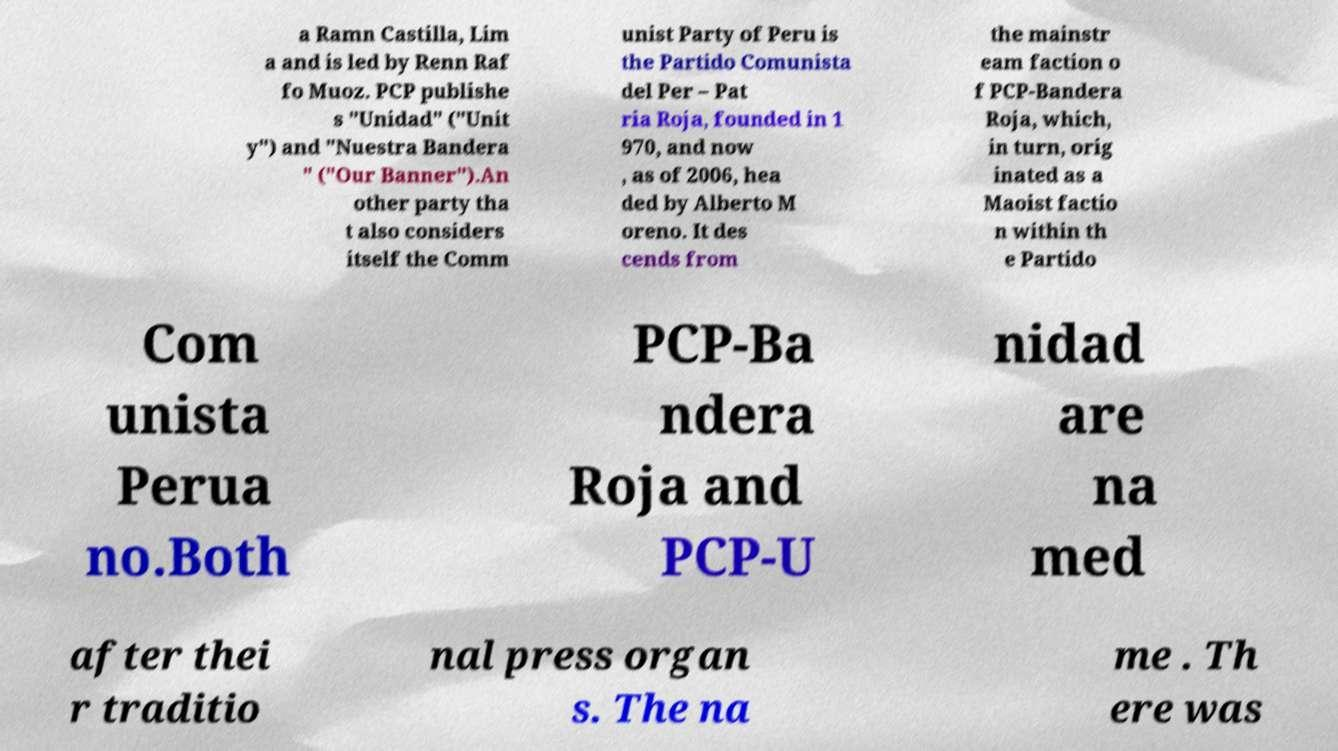I need the written content from this picture converted into text. Can you do that? a Ramn Castilla, Lim a and is led by Renn Raf fo Muoz. PCP publishe s "Unidad" ("Unit y") and "Nuestra Bandera " ("Our Banner").An other party tha t also considers itself the Comm unist Party of Peru is the Partido Comunista del Per – Pat ria Roja, founded in 1 970, and now , as of 2006, hea ded by Alberto M oreno. It des cends from the mainstr eam faction o f PCP-Bandera Roja, which, in turn, orig inated as a Maoist factio n within th e Partido Com unista Perua no.Both PCP-Ba ndera Roja and PCP-U nidad are na med after thei r traditio nal press organ s. The na me . Th ere was 